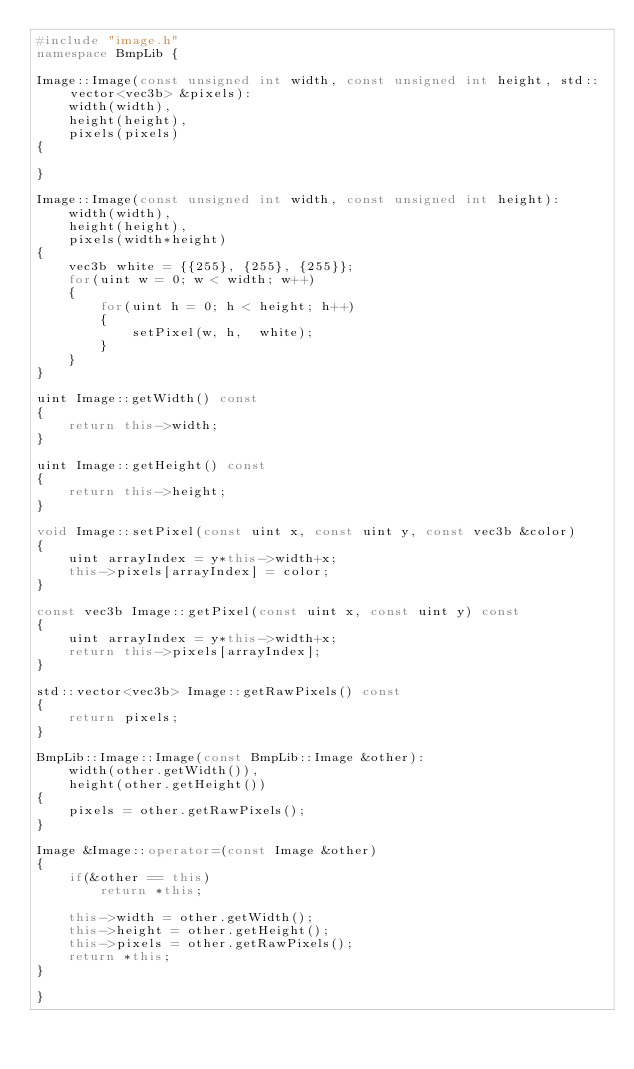Convert code to text. <code><loc_0><loc_0><loc_500><loc_500><_C++_>#include "image.h"
namespace BmpLib {

Image::Image(const unsigned int width, const unsigned int height, std::vector<vec3b> &pixels):
    width(width),
    height(height),
    pixels(pixels)
{

}

Image::Image(const unsigned int width, const unsigned int height):
    width(width),
    height(height),
    pixels(width*height)
{
    vec3b white = {{255}, {255}, {255}};
    for(uint w = 0; w < width; w++)
    {
        for(uint h = 0; h < height; h++)
        {
            setPixel(w, h,  white);
        }
    }
}

uint Image::getWidth() const
{
    return this->width;
}

uint Image::getHeight() const
{
    return this->height;
}

void Image::setPixel(const uint x, const uint y, const vec3b &color)
{
    uint arrayIndex = y*this->width+x;
    this->pixels[arrayIndex] = color;
}

const vec3b Image::getPixel(const uint x, const uint y) const
{
    uint arrayIndex = y*this->width+x;
    return this->pixels[arrayIndex];
}

std::vector<vec3b> Image::getRawPixels() const
{
    return pixels;
}

BmpLib::Image::Image(const BmpLib::Image &other):
    width(other.getWidth()),
    height(other.getHeight())
{
    pixels = other.getRawPixels();
}

Image &Image::operator=(const Image &other)
{
    if(&other == this)
        return *this;

    this->width = other.getWidth();
    this->height = other.getHeight();
    this->pixels = other.getRawPixels();
    return *this;
}

}
</code> 